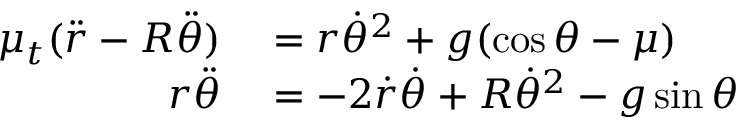Convert formula to latex. <formula><loc_0><loc_0><loc_500><loc_500>\begin{array} { r l } { \mu _ { t } ( { \ddot { r } } - R { \ddot { \theta } } ) } & = r { \dot { \theta } } ^ { 2 } + g ( \cos { \theta } - \mu ) } \\ { r { \ddot { \theta } } } & = - 2 { \dot { r } } { \dot { \theta } } + R { \dot { \theta } } ^ { 2 } - g \sin { \theta } } \end{array}</formula> 